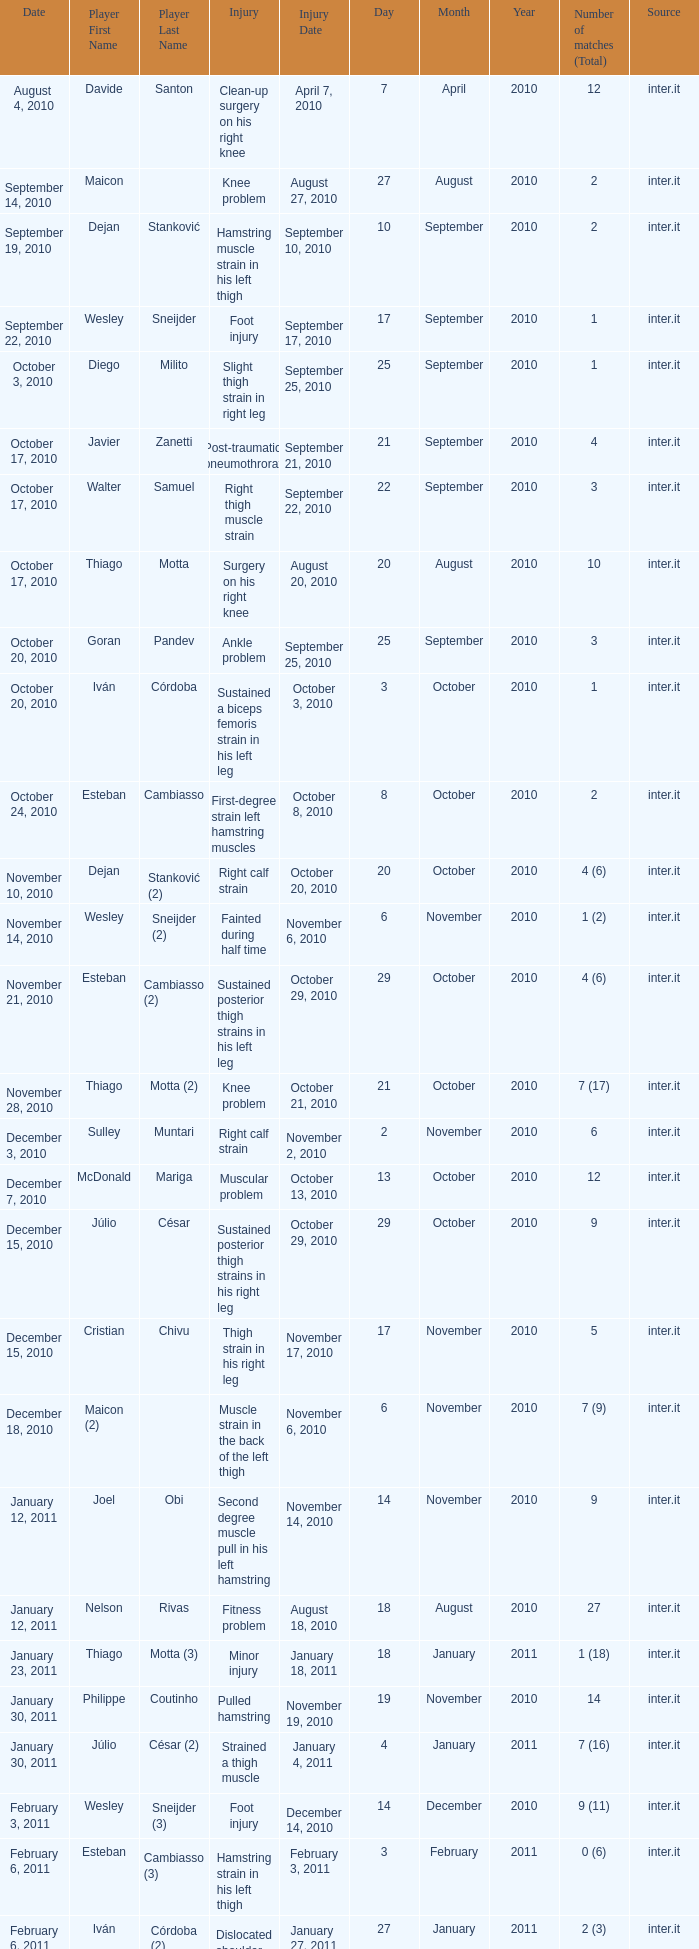How many times was the date october 3, 2010? 1.0. 